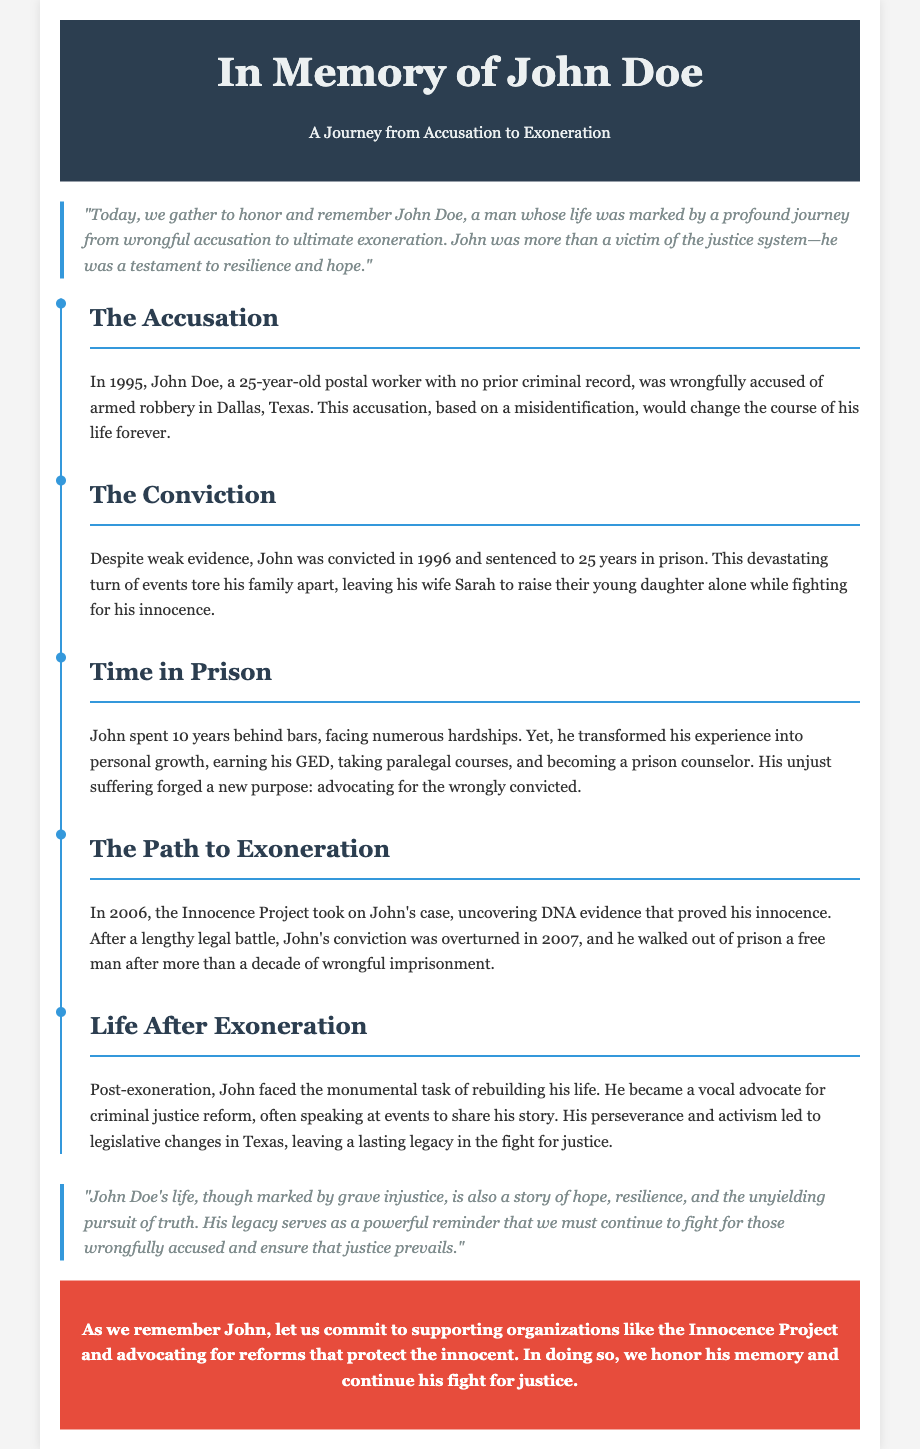What year was John Doe wrongfully accused? The document states that John Doe was wrongfully accused in 1995.
Answer: 1995 How long did John spend in prison? The document mentions that John spent 10 years behind bars.
Answer: 10 years Who took on John's case in 2006? The document states that the Innocence Project took on John's case.
Answer: Innocence Project In what year was John's conviction overturned? The document indicates that John's conviction was overturned in 2007.
Answer: 2007 What was John's original sentence? The document states that John was sentenced to 25 years in prison.
Answer: 25 years What did John earn while in prison? The document mentions that John earned his GED while incarcerated.
Answer: GED What did John become post-exoneration? The document states that John became a vocal advocate for criminal justice reform.
Answer: Advocate What major change did John advocate for? The document mentions that John's activism led to legislative changes in Texas.
Answer: Legislative changes 